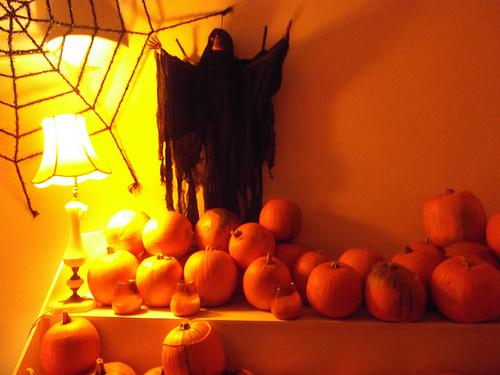Detect the presence of any unconventional objects in the image associated with the celebration. No unconventional objects are detected in the image; all items are commonly associated with Halloween celebrations. Based on the objects in the image, predict what event is being celebrated. The event being celebrated is Halloween, as there are pumpkins and skeleton decorations in the image. Identify the Halloween themed decoration hanging on the wall. A black spider web decoration is hanging on the wall near the top-left corner of the image. Perform a sentiment analysis of the image, taking into account the context and objects present. The sentiment of the image is festive and spooky, considering the Halloween decorations and pumpkins, with an overall sense of fun and celebration. What type of light fixture is present in the image and is it turned on or off? There is a narrow white lamp with a yellow lampshade in the image, and it appears to be turned on. Count the number of candles visible in the image and describe their state. There are three small candles: one looks burnt out, one has a blackened top, and the third is full of wax. What is the color of the wall in the image? The wall color in the image is orange. Describe the position and appearance of the skeleton in the image. The white skeleton is dressed in a black flowing garment and is positioned near the top-left corner, rising above the pumpkins and outstretching its arms. Provide a description of the pumpkin with the most unique coloration in the image. The pumpkin with the most unique coloration is the one with green coloring over half of it, located towards the top-right corner. Identify the object that is keeping the pumpkins from falling and where it is located. A white board is keeping the pumpkins from falling, located on the left side of the image near the middle. 